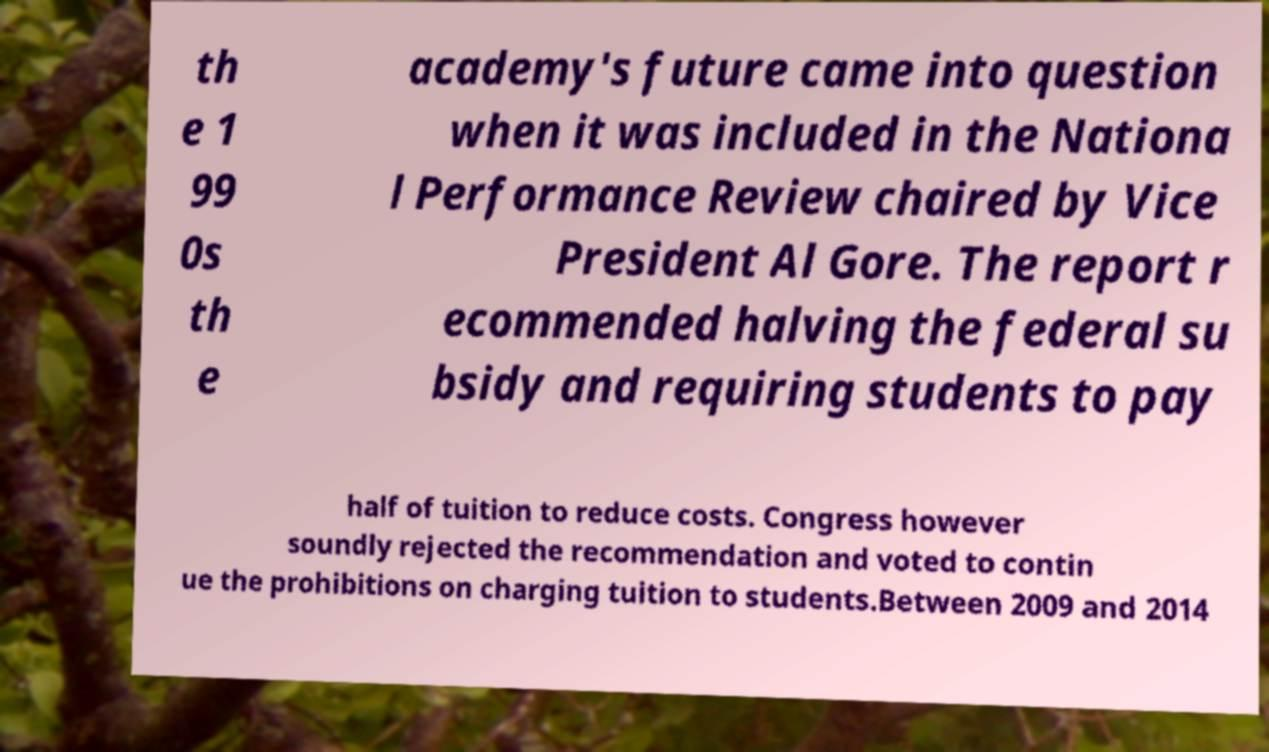Please read and relay the text visible in this image. What does it say? th e 1 99 0s th e academy's future came into question when it was included in the Nationa l Performance Review chaired by Vice President Al Gore. The report r ecommended halving the federal su bsidy and requiring students to pay half of tuition to reduce costs. Congress however soundly rejected the recommendation and voted to contin ue the prohibitions on charging tuition to students.Between 2009 and 2014 